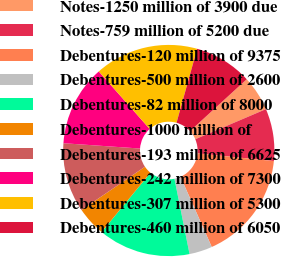Convert chart to OTSL. <chart><loc_0><loc_0><loc_500><loc_500><pie_chart><fcel>Notes-1250 million of 3900 due<fcel>Notes-759 million of 5200 due<fcel>Debentures-120 million of 9375<fcel>Debentures-500 million of 2600<fcel>Debentures-82 million of 8000<fcel>Debentures-1000 million of<fcel>Debentures-193 million of 6625<fcel>Debentures-242 million of 7300<fcel>Debentures-307 million of 5300<fcel>Debentures-460 million of 6050<nl><fcel>5.38%<fcel>8.0%<fcel>16.74%<fcel>3.52%<fcel>14.12%<fcel>4.51%<fcel>10.62%<fcel>12.37%<fcel>15.86%<fcel>8.88%<nl></chart> 